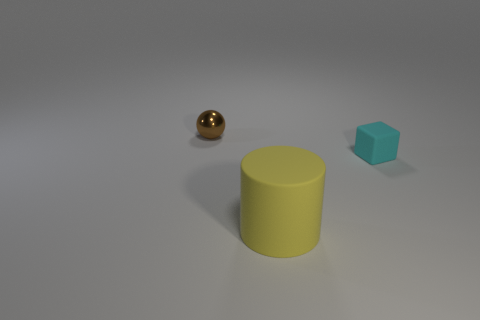Add 1 large things. How many objects exist? 4 Subtract all balls. How many objects are left? 2 Add 3 brown objects. How many brown objects exist? 4 Subtract 0 purple cubes. How many objects are left? 3 Subtract all small cyan cubes. Subtract all shiny objects. How many objects are left? 1 Add 2 big yellow things. How many big yellow things are left? 3 